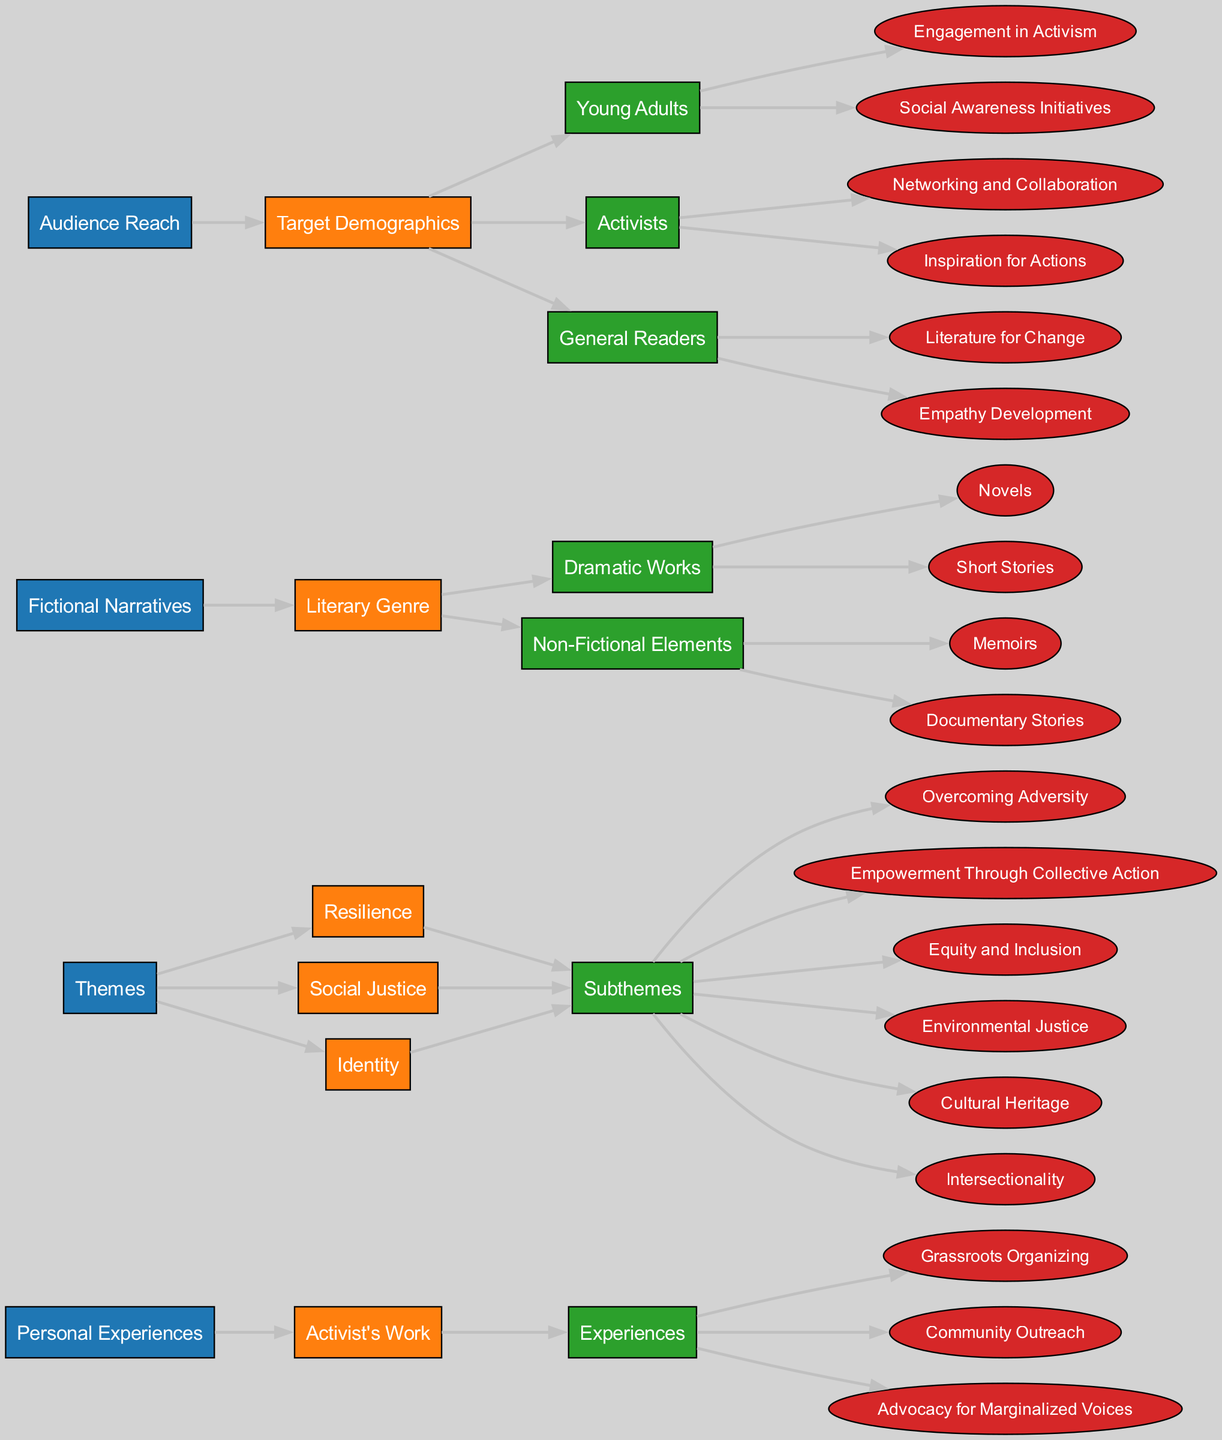What are the three main categories of personal experiences? The diagram shows that the three main categories under "Personal Experiences" are "Grassroots Organizing," "Community Outreach," and "Advocacy for Marginalized Voices." These are listed as subcategories.
Answer: Grassroots Organizing, Community Outreach, Advocacy for Marginalized Voices How many subthemes are included under the theme of "Identity"? The theme "Identity" includes two subthemes: "Cultural Heritage" and "Intersectionality." The count of subthemes can be directly obtained from this part of the diagram.
Answer: 2 What is the primary theme that connects to "Novels"? The diagram indicates that "Dramatic Works," which includes "Novels," connects to the themes of "Resilience," "Social Justice," and "Identity," showcasing a diverse thematic connection. The primary theme is not explicitly stated, and it would depend on the focus of the narrative.
Answer: Resilience, Social Justice, Identity Which target demographic is associated with "Social Awareness Initiatives"? The target demographic associated with "Social Awareness Initiatives" is "Young Adults," as shown in the diagram where this demographic lists specific initiatives connected to their engagement in activism and related areas.
Answer: Young Adults What is the relationship between "Environmental Justice" and "Activists"? The diagram visually connects "Environmental Justice" under the theme of "Social Justice" to the demographic of "Activists". Activists are inspired through themes related to social justice, including environmental issues.
Answer: Activists Which literary genre includes "Memoirs"? "Memoirs" are categorized under the "Non-Fictional Elements" of the "Fictional Narratives" section. The relationship is clearly depicted in the diagram that separates literary genres into different forms.
Answer: Non-Fictional Elements 